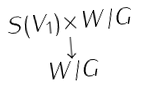Convert formula to latex. <formula><loc_0><loc_0><loc_500><loc_500>\begin{smallmatrix} S ( V _ { 1 } ) \times W / G \\ \downarrow \\ W / G \end{smallmatrix}</formula> 